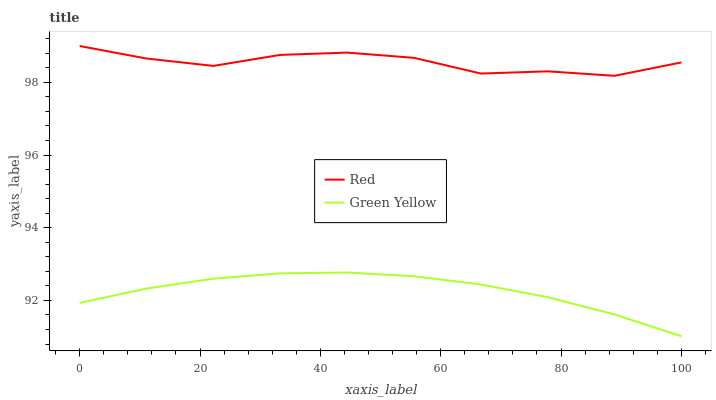Does Green Yellow have the minimum area under the curve?
Answer yes or no. Yes. Does Red have the maximum area under the curve?
Answer yes or no. Yes. Does Red have the minimum area under the curve?
Answer yes or no. No. Is Green Yellow the smoothest?
Answer yes or no. Yes. Is Red the roughest?
Answer yes or no. Yes. Is Red the smoothest?
Answer yes or no. No. Does Green Yellow have the lowest value?
Answer yes or no. Yes. Does Red have the lowest value?
Answer yes or no. No. Does Red have the highest value?
Answer yes or no. Yes. Is Green Yellow less than Red?
Answer yes or no. Yes. Is Red greater than Green Yellow?
Answer yes or no. Yes. Does Green Yellow intersect Red?
Answer yes or no. No. 